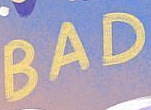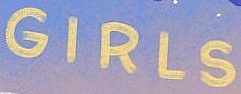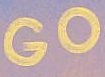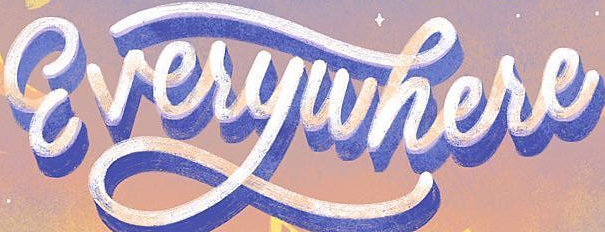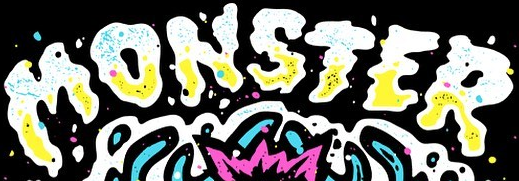Identify the words shown in these images in order, separated by a semicolon. BAD; GIRLS; GO; Everywhere; MONSTER 